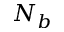<formula> <loc_0><loc_0><loc_500><loc_500>N _ { b }</formula> 